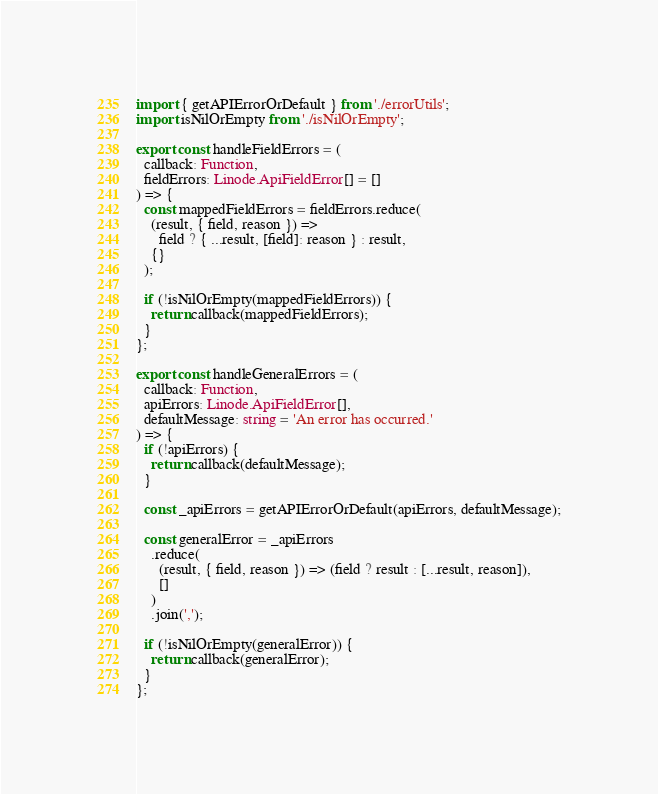Convert code to text. <code><loc_0><loc_0><loc_500><loc_500><_TypeScript_>import { getAPIErrorOrDefault } from './errorUtils';
import isNilOrEmpty from './isNilOrEmpty';

export const handleFieldErrors = (
  callback: Function,
  fieldErrors: Linode.ApiFieldError[] = []
) => {
  const mappedFieldErrors = fieldErrors.reduce(
    (result, { field, reason }) =>
      field ? { ...result, [field]: reason } : result,
    {}
  );

  if (!isNilOrEmpty(mappedFieldErrors)) {
    return callback(mappedFieldErrors);
  }
};

export const handleGeneralErrors = (
  callback: Function,
  apiErrors: Linode.ApiFieldError[],
  defaultMessage: string = 'An error has occurred.'
) => {
  if (!apiErrors) {
    return callback(defaultMessage);
  }

  const _apiErrors = getAPIErrorOrDefault(apiErrors, defaultMessage);

  const generalError = _apiErrors
    .reduce(
      (result, { field, reason }) => (field ? result : [...result, reason]),
      []
    )
    .join(',');

  if (!isNilOrEmpty(generalError)) {
    return callback(generalError);
  }
};
</code> 